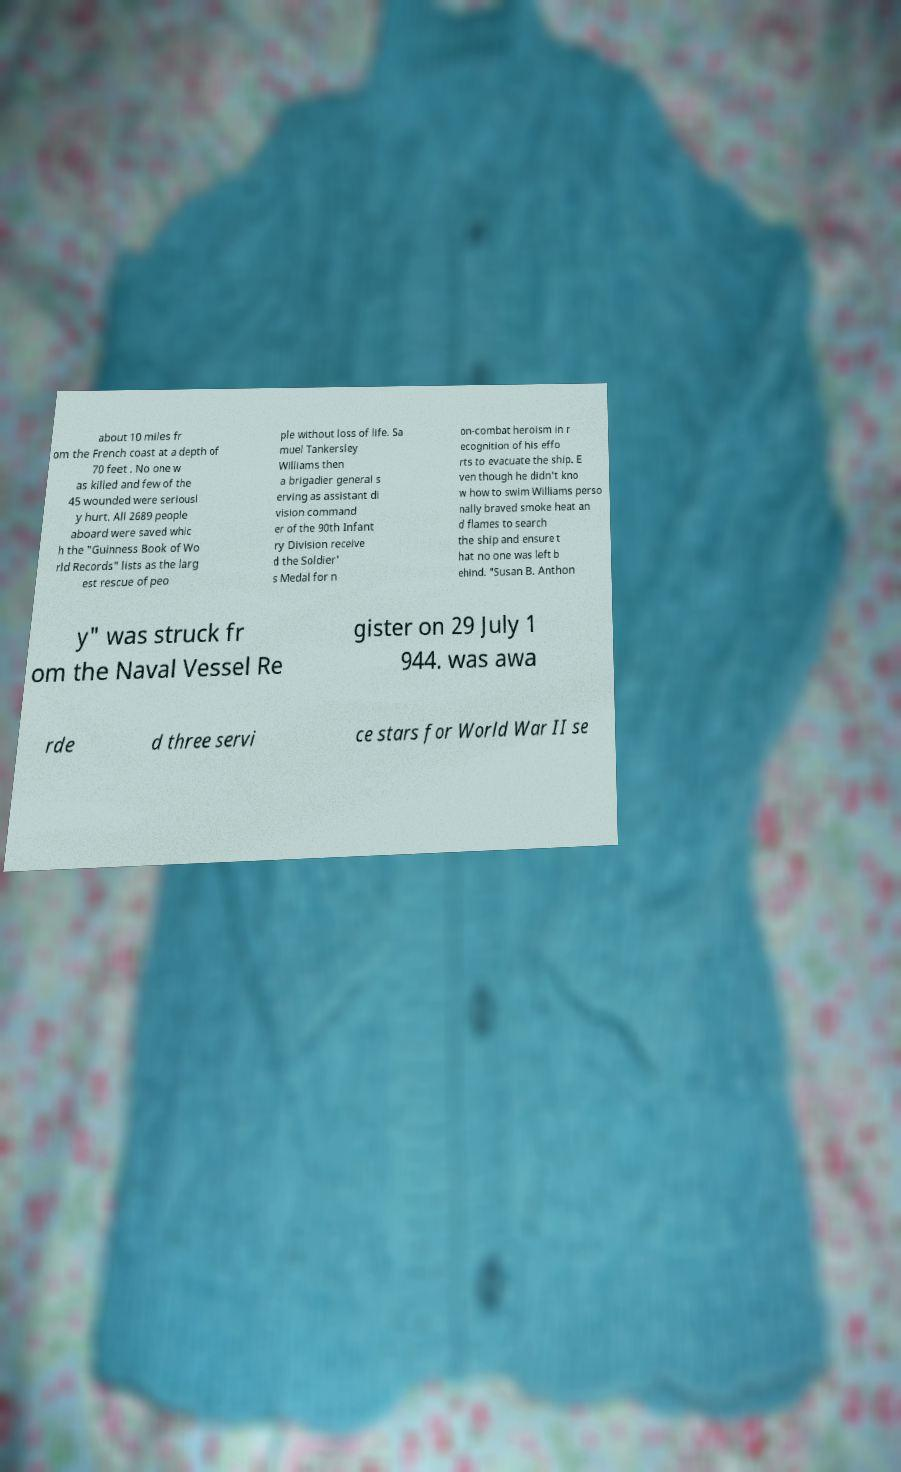Please identify and transcribe the text found in this image. about 10 miles fr om the French coast at a depth of 70 feet . No one w as killed and few of the 45 wounded were seriousl y hurt. All 2689 people aboard were saved whic h the "Guinness Book of Wo rld Records" lists as the larg est rescue of peo ple without loss of life. Sa muel Tankersley Williams then a brigadier general s erving as assistant di vision command er of the 90th Infant ry Division receive d the Soldier' s Medal for n on-combat heroism in r ecognition of his effo rts to evacuate the ship. E ven though he didn't kno w how to swim Williams perso nally braved smoke heat an d flames to search the ship and ensure t hat no one was left b ehind. "Susan B. Anthon y" was struck fr om the Naval Vessel Re gister on 29 July 1 944. was awa rde d three servi ce stars for World War II se 